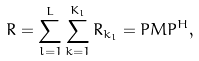<formula> <loc_0><loc_0><loc_500><loc_500>R = \sum _ { l = 1 } ^ { L } \sum _ { k = 1 } ^ { K _ { l } } R _ { k _ { l } } = P M P ^ { H } ,</formula> 